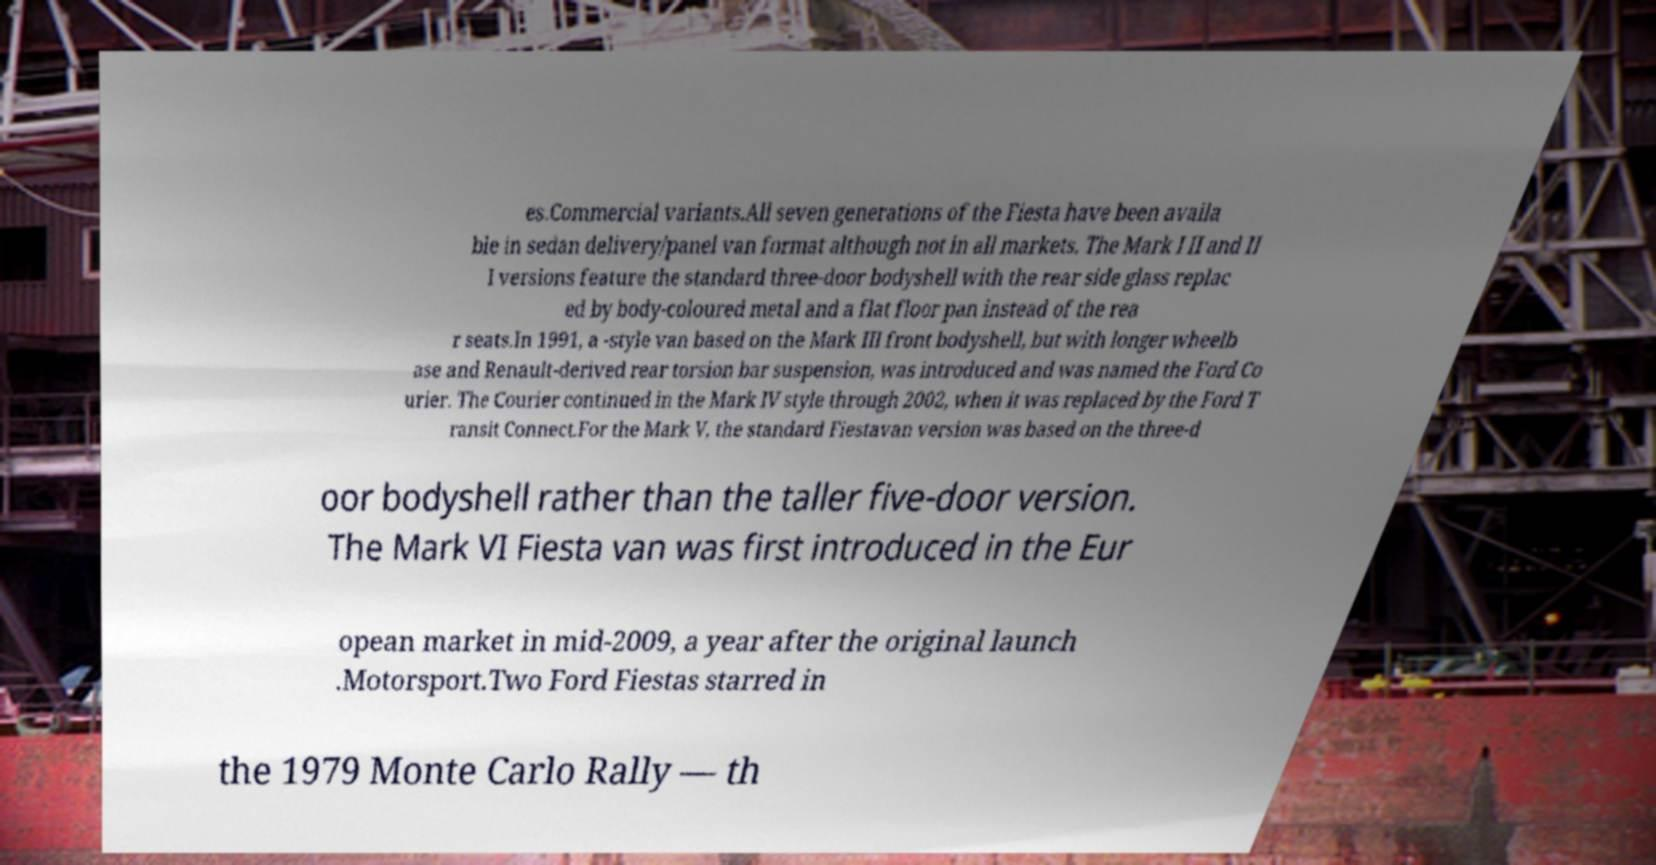Can you accurately transcribe the text from the provided image for me? es.Commercial variants.All seven generations of the Fiesta have been availa ble in sedan delivery/panel van format although not in all markets. The Mark I II and II I versions feature the standard three-door bodyshell with the rear side glass replac ed by body-coloured metal and a flat floor pan instead of the rea r seats.In 1991, a -style van based on the Mark III front bodyshell, but with longer wheelb ase and Renault-derived rear torsion bar suspension, was introduced and was named the Ford Co urier. The Courier continued in the Mark IV style through 2002, when it was replaced by the Ford T ransit Connect.For the Mark V, the standard Fiestavan version was based on the three-d oor bodyshell rather than the taller five-door version. The Mark VI Fiesta van was first introduced in the Eur opean market in mid-2009, a year after the original launch .Motorsport.Two Ford Fiestas starred in the 1979 Monte Carlo Rally — th 